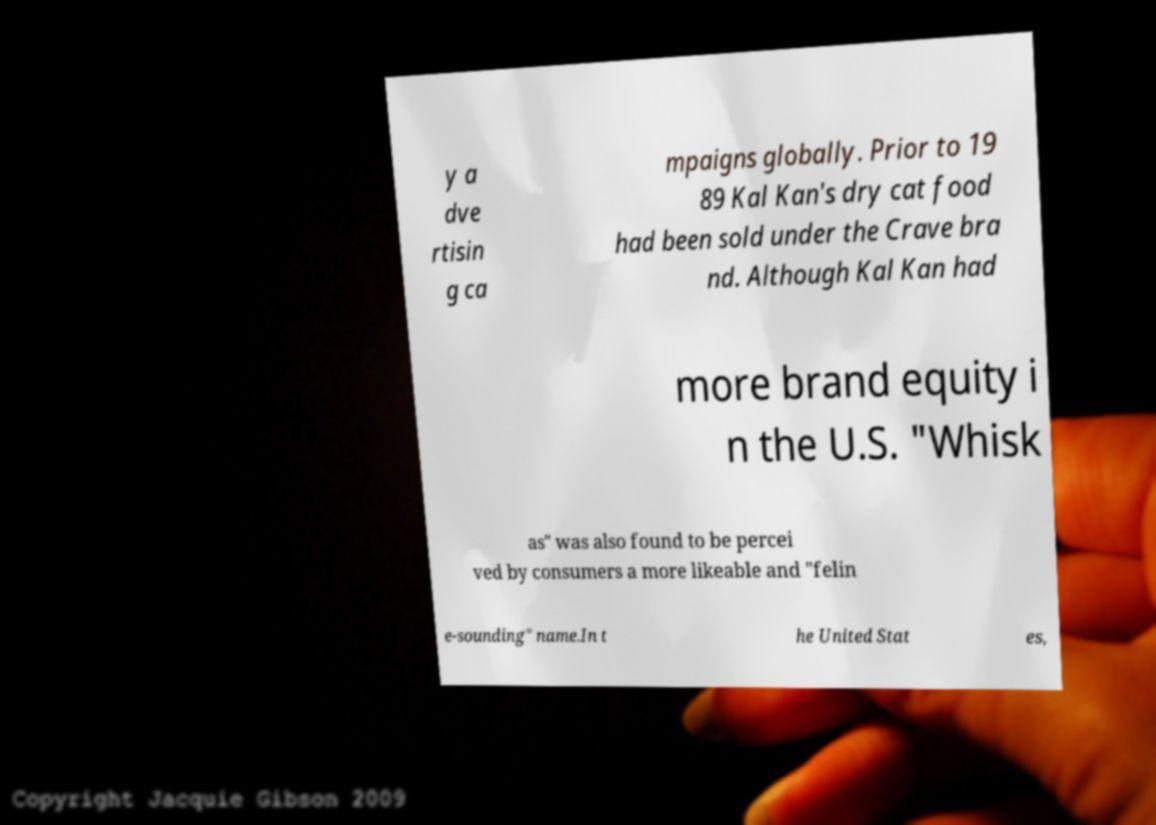There's text embedded in this image that I need extracted. Can you transcribe it verbatim? y a dve rtisin g ca mpaigns globally. Prior to 19 89 Kal Kan's dry cat food had been sold under the Crave bra nd. Although Kal Kan had more brand equity i n the U.S. "Whisk as" was also found to be percei ved by consumers a more likeable and "felin e-sounding" name.In t he United Stat es, 